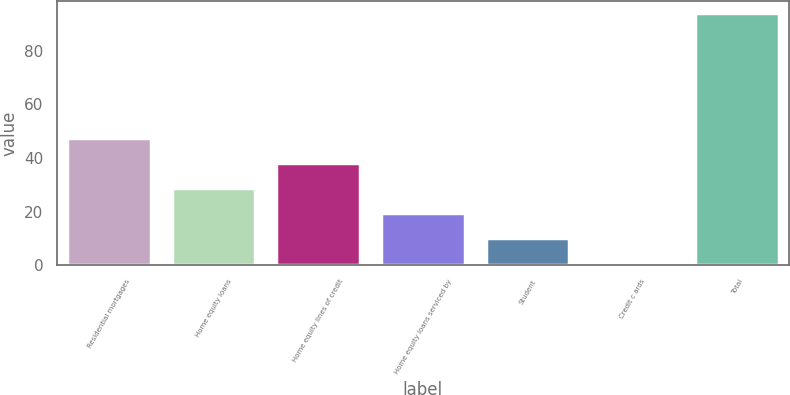<chart> <loc_0><loc_0><loc_500><loc_500><bar_chart><fcel>Residential mortgages<fcel>Home equity loans<fcel>Home equity lines of credit<fcel>Home equity loans serviced by<fcel>Student<fcel>Credit c ards<fcel>Total<nl><fcel>47.5<fcel>28.9<fcel>38.2<fcel>19.6<fcel>10.3<fcel>1<fcel>94<nl></chart> 